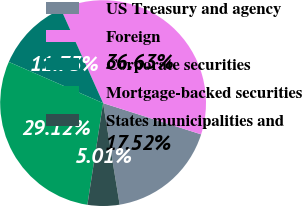<chart> <loc_0><loc_0><loc_500><loc_500><pie_chart><fcel>US Treasury and agency<fcel>Foreign<fcel>Corporate securities<fcel>Mortgage-backed securities<fcel>States municipalities and<nl><fcel>17.52%<fcel>36.63%<fcel>11.73%<fcel>29.12%<fcel>5.01%<nl></chart> 